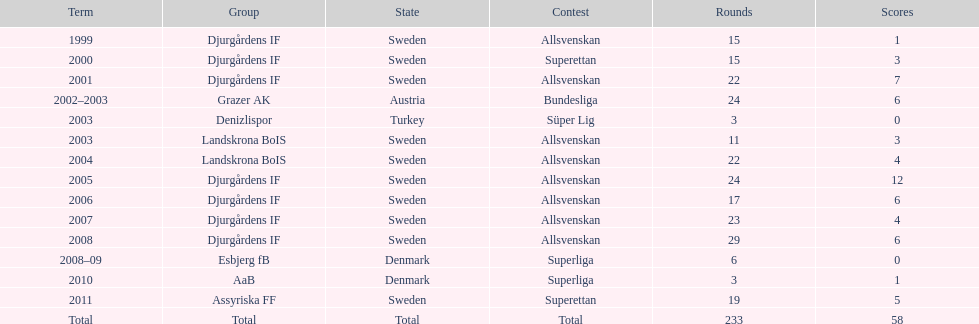How many total goals has jones kusi-asare scored? 58. 